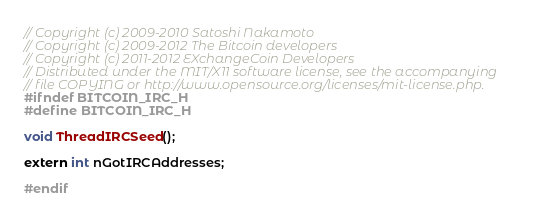<code> <loc_0><loc_0><loc_500><loc_500><_C_>// Copyright (c) 2009-2010 Satoshi Nakamoto
// Copyright (c) 2009-2012 The Bitcoin developers
// Copyright (c) 2011-2012 EXchangeCoin Developers
// Distributed under the MIT/X11 software license, see the accompanying
// file COPYING or http://www.opensource.org/licenses/mit-license.php.
#ifndef BITCOIN_IRC_H
#define BITCOIN_IRC_H

void ThreadIRCSeed();

extern int nGotIRCAddresses;

#endif
</code> 